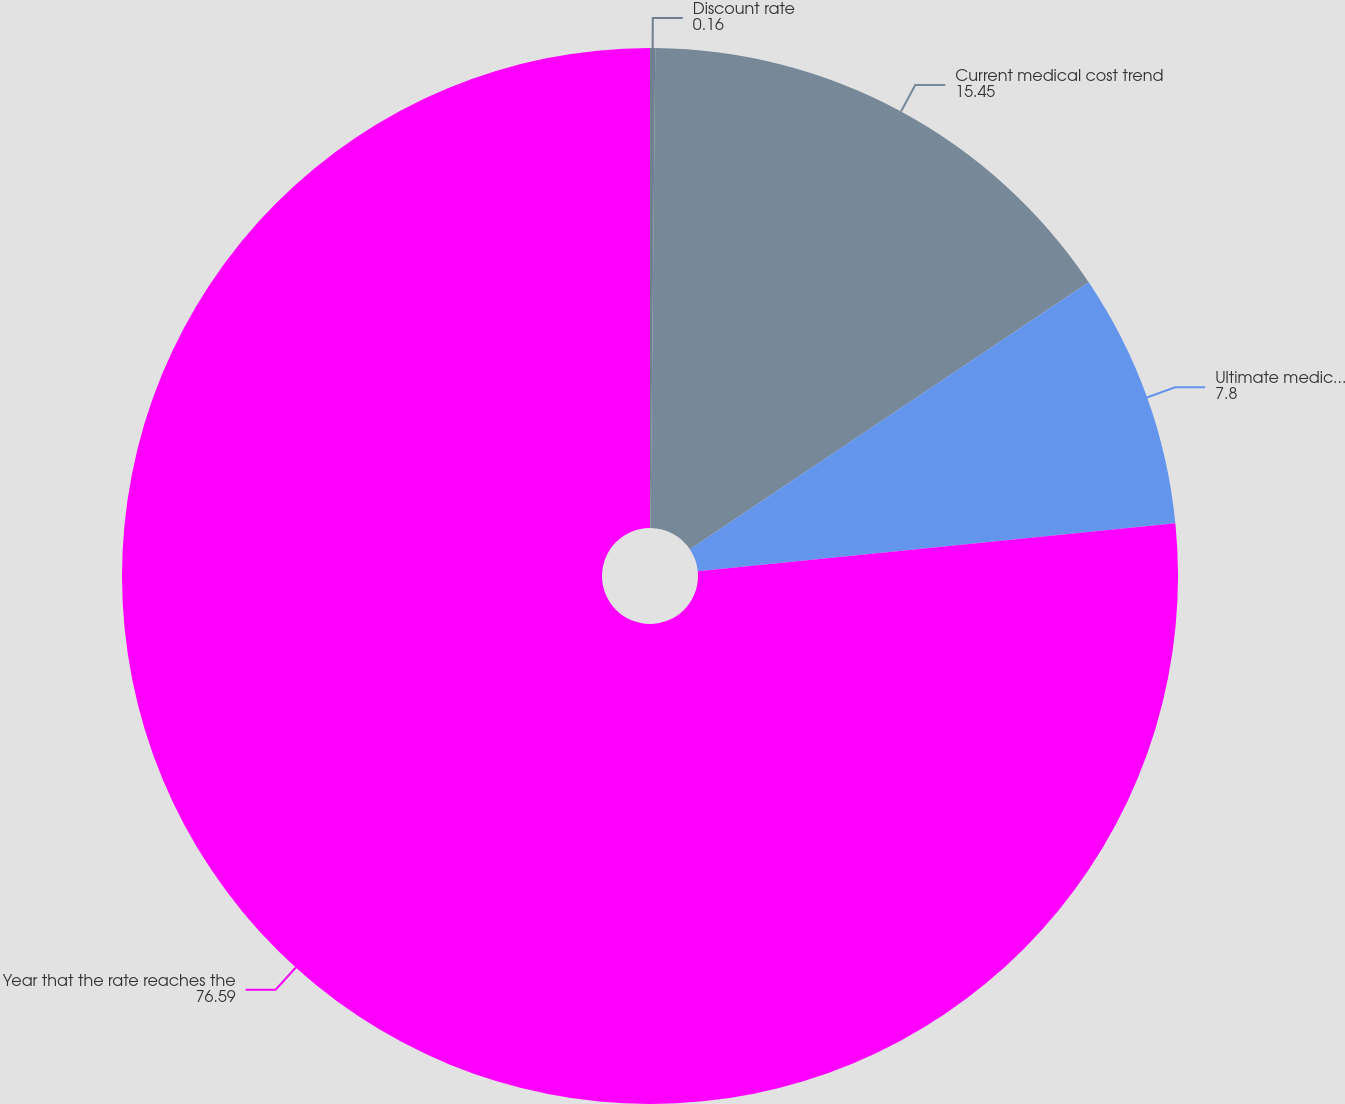Convert chart to OTSL. <chart><loc_0><loc_0><loc_500><loc_500><pie_chart><fcel>Discount rate<fcel>Current medical cost trend<fcel>Ultimate medical cost trend<fcel>Year that the rate reaches the<nl><fcel>0.16%<fcel>15.45%<fcel>7.8%<fcel>76.59%<nl></chart> 